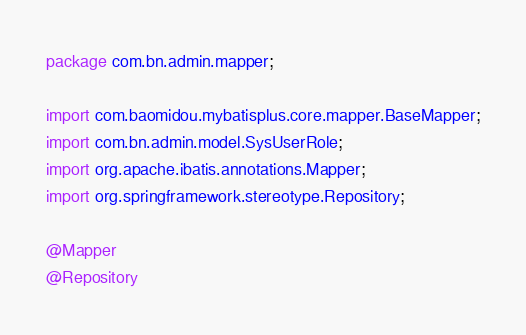Convert code to text. <code><loc_0><loc_0><loc_500><loc_500><_Java_>package com.bn.admin.mapper;

import com.baomidou.mybatisplus.core.mapper.BaseMapper;
import com.bn.admin.model.SysUserRole;
import org.apache.ibatis.annotations.Mapper;
import org.springframework.stereotype.Repository;

@Mapper
@Repository</code> 